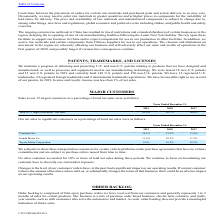From Cts Corporation's financial document, Which years does the table provide information for the company's net sales to significant customers as a percentage of total net sales? The document contains multiple relevant values: 2019, 2018, 2017. From the document: "2019 2018 2017 2019 2018 2017 2019 2018 2017..." Also, What was the percentage of total net sales occupied by Cummins Inc. in 2017? According to the financial document, 13.4 (percentage). The relevant text states: "Cummins Inc. 16.1% 15.2% 13.4%..." Also, What was the percentage of total net sales occupied by Honda Motor Co. in 2019? According to the financial document, 11.6 (percentage). The relevant text states: "Honda Motor Co. 11.6% 10.5% 11.2%..." Also, How many years did Cummins Inc. occupy more than 15% of the company's total net sales? Counting the relevant items in the document: 2019, 2018, I find 2 instances. The key data points involved are: 2018, 2019. Also, can you calculate: What was the change in the percentage of total net sales from Honda Motor Co. between 2017 and 2018? Based on the calculation: 10.5-11.2, the result is -0.7 (percentage). This is based on the information: "Honda Motor Co. 11.6% 10.5% 11.2% Honda Motor Co. 11.6% 10.5% 11.2%..." The key data points involved are: 10.5, 11.2. Also, can you calculate: What was the sum of the percentages of total net sales between Honda Motor Co. and Toyota Motor Corporation in 2017? Based on the calculation: 11.2+10.2, the result is 21.4 (percentage). This is based on the information: "Toyota Motor Corporation 9.6% 10.5% 10.2% Honda Motor Co. 11.6% 10.5% 11.2%..." The key data points involved are: 10.2, 11.2. 